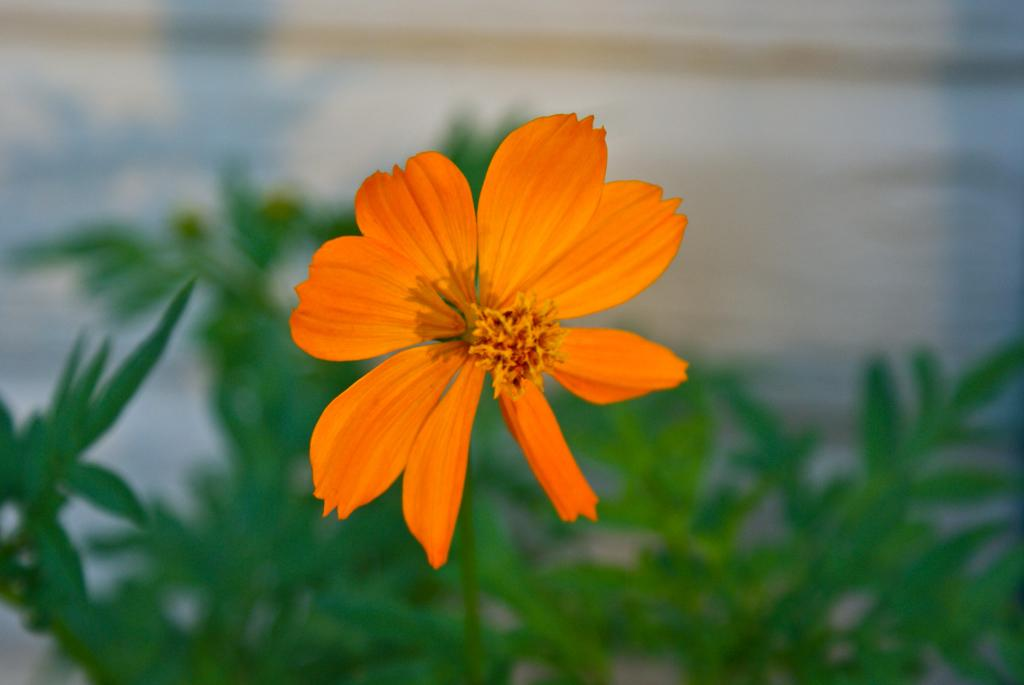What type of plant is in the picture? There is a flower plant in the picture. What color is the flower on the plant? The flower is orange in color. Can you describe the background of the image? The background of the image is blurred. How many pins are holding the riddle in the image? There is no riddle or pins present in the image; it features a flower plant with an orange flower and a blurred background. 